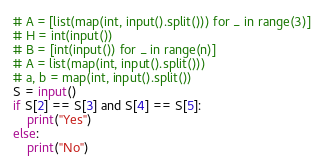Convert code to text. <code><loc_0><loc_0><loc_500><loc_500><_Python_># A = [list(map(int, input().split())) for _ in range(3)]
# H = int(input())
# B = [int(input()) for _ in range(n)]
# A = list(map(int, input().split()))
# a, b = map(int, input().split())
S = input()
if S[2] == S[3] and S[4] == S[5]:
    print("Yes")
else:
    print("No")
</code> 